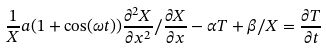<formula> <loc_0><loc_0><loc_500><loc_500>\frac { 1 } { X } a ( 1 + \cos ( \omega t ) ) \frac { \partial ^ { 2 } X } { \partial x ^ { 2 } } / \frac { \partial X } { \partial x } - \alpha T + \beta / X = \frac { \partial T } { \partial t }</formula> 